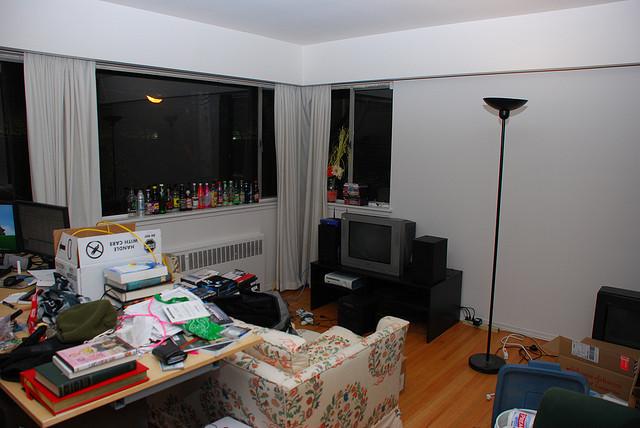What's on the long window sill?
Be succinct. Bottles. Can you see a tea set?
Quick response, please. No. What color is the lampshade?
Answer briefly. Black. What type of house is this?
Give a very brief answer. Apartment. Are family pictures on the wall?
Keep it brief. No. Is it daytime?
Keep it brief. No. What is the condition of the floor?
Short answer required. Good. What number of windows are in this room?
Write a very short answer. 3. Why are there curtains in front of the window?
Quick response, please. Privacy. Is there a curtain on the window?
Write a very short answer. Yes. What kind of books are these?
Short answer required. Textbooks. Is this a kitchen?
Quick response, please. No. Are these exposed beams?
Keep it brief. No. Was the photo taken at night?
Concise answer only. Yes. Is hello kitty in this scene?
Short answer required. No. Is the tv on?
Concise answer only. No. Is there a fire extinguisher in the picture?
Answer briefly. No. Does a person work or play here?
Answer briefly. Play. Is this a workshop?
Write a very short answer. No. What color is the floor?
Write a very short answer. Brown. Where was this picture taken?
Keep it brief. Living room. What are the toppings stored in?
Concise answer only. Box. Is there a clock in the picture?
Give a very brief answer. No. Is the lamp off?
Give a very brief answer. Yes. Is this a toy family?
Write a very short answer. No. How many lamps shades are there?
Quick response, please. 1. What has been piled up?
Be succinct. Books. Is it daytime or night time?
Short answer required. Night. Is there a couch in this room?
Give a very brief answer. Yes. Is the room organized?
Answer briefly. No. Could you assemble a 500 piece puzzle on the table in its present condition?
Write a very short answer. No. How many windows?
Be succinct. 3. What material is the coach made out of?
Write a very short answer. Cloth. Is this an office?
Keep it brief. No. Is the computer on?
Short answer required. No. Is there a plant inside the room?
Be succinct. No. Is this a camper?
Answer briefly. No. Is it daytime outside?
Be succinct. No. What pattern is on the chair?
Give a very brief answer. Floral. Is this a real image?
Give a very brief answer. Yes. What is placed in the windowsill?
Concise answer only. Bottles. What textile is the couch?
Short answer required. Floral. What color is the chair seat?
Quick response, please. White. Where is the desk lamp?
Write a very short answer. On floor. Where in the room is this?
Be succinct. Living room. Is it sunny outside?
Concise answer only. No. What is behind the table?
Concise answer only. Couch. What room is this?
Write a very short answer. Living room. What color is the chair that has a headrest?
Give a very brief answer. White. Where is the unlit desk lamp?
Concise answer only. Floor. 